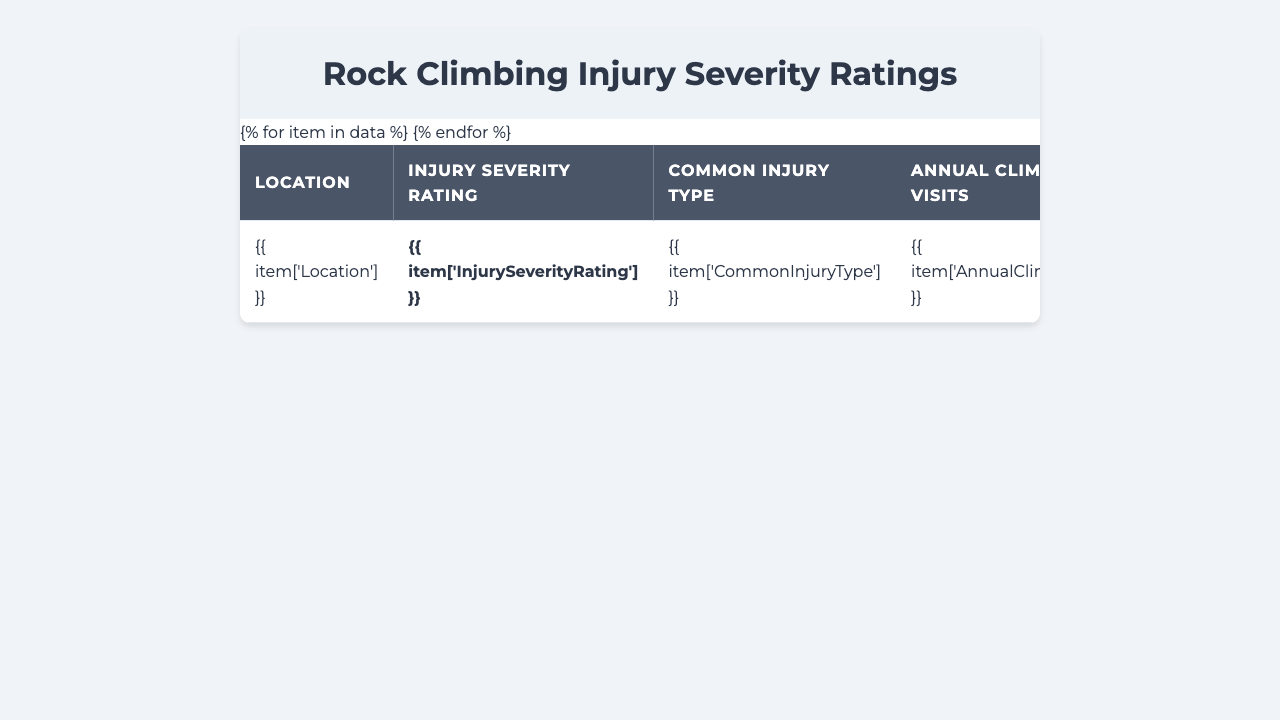What is the injury severity rating for Yosemite National Park? The table displays the injury severity rating for Yosemite National Park, which is 7.2.
Answer: 7.2 Which location has the highest injury severity rating? By reviewing the ratings in the table, Yosemite National Park has the highest injury severity rating at 7.2.
Answer: Yosemite National Park What is the common injury type at Kalymnos, Greece? The table indicates that the common injury type at Kalymnos, Greece is sprains.
Answer: Sprains What is the average injury severity rating of the top three locations by severity? The top three locations by severity are Yosemite National Park (7.2), El Chorro (6.9), and Squamish (6.7). Their total rating is 20.8; dividing by 3 gives an average of approximately 6.93.
Answer: 6.93 How many annual climber visits does Railay Beach, Thailand receive? The table provides the information that Railay Beach receives 75,000 annual climber visits.
Answer: 75,000 Is the emergency response time shorter at Fontainebleau, France than at Siurana, Spain? The emergency response time for Fontainebleau is 20 minutes, while Siurana's is 25 minutes. Thus, Fontainebleau has a shorter response time.
Answer: Yes What is the difference in injury severity rating between Yosemite National Park and Railay Beach? Yosemite National Park has an injury severity rating of 7.2 and Railay Beach has a rating of 5.3. The difference is 7.2 - 5.3 = 1.9.
Answer: 1.9 Which location has the longest emergency response time? By comparing the emergency response times in the table, Railay Beach has the longest response time at 50 minutes.
Answer: Railay Beach What is the total number of annual climber visits across all locations? Adding the annual climber visits for all locations gives a total of 150,000 + 80,000 + 100,000 + 70,000 + 95,000 + 60,000 + 110,000 + 75,000 + 55,000 + 65,000 = 1,020,000.
Answer: 1,020,000 What injury type is most common at locations with a severity rating above 6? Checking the locations with a severity rating above 6 (Yosemite, El Chorro, Squamish, and Red River Gorge), the common injury types are fractures, lacerations, head injuries, and dislocations.
Answer: Fractures, lacerations, head injuries, dislocations 